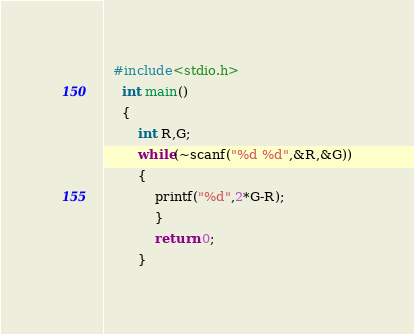<code> <loc_0><loc_0><loc_500><loc_500><_C_>  #include<stdio.h>
    int main()
    {
    	int R,G;
    	while(~scanf("%d %d",&R,&G))
    	{
    		printf("%d",2*G-R);
    		}
    		return 0;
    	}</code> 